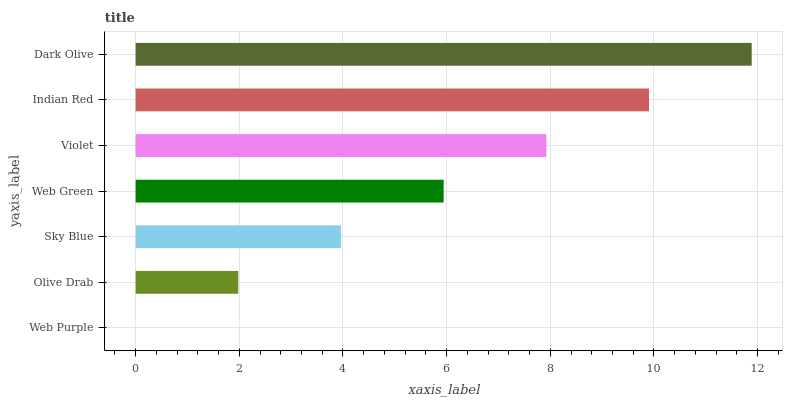Is Web Purple the minimum?
Answer yes or no. Yes. Is Dark Olive the maximum?
Answer yes or no. Yes. Is Olive Drab the minimum?
Answer yes or no. No. Is Olive Drab the maximum?
Answer yes or no. No. Is Olive Drab greater than Web Purple?
Answer yes or no. Yes. Is Web Purple less than Olive Drab?
Answer yes or no. Yes. Is Web Purple greater than Olive Drab?
Answer yes or no. No. Is Olive Drab less than Web Purple?
Answer yes or no. No. Is Web Green the high median?
Answer yes or no. Yes. Is Web Green the low median?
Answer yes or no. Yes. Is Indian Red the high median?
Answer yes or no. No. Is Olive Drab the low median?
Answer yes or no. No. 